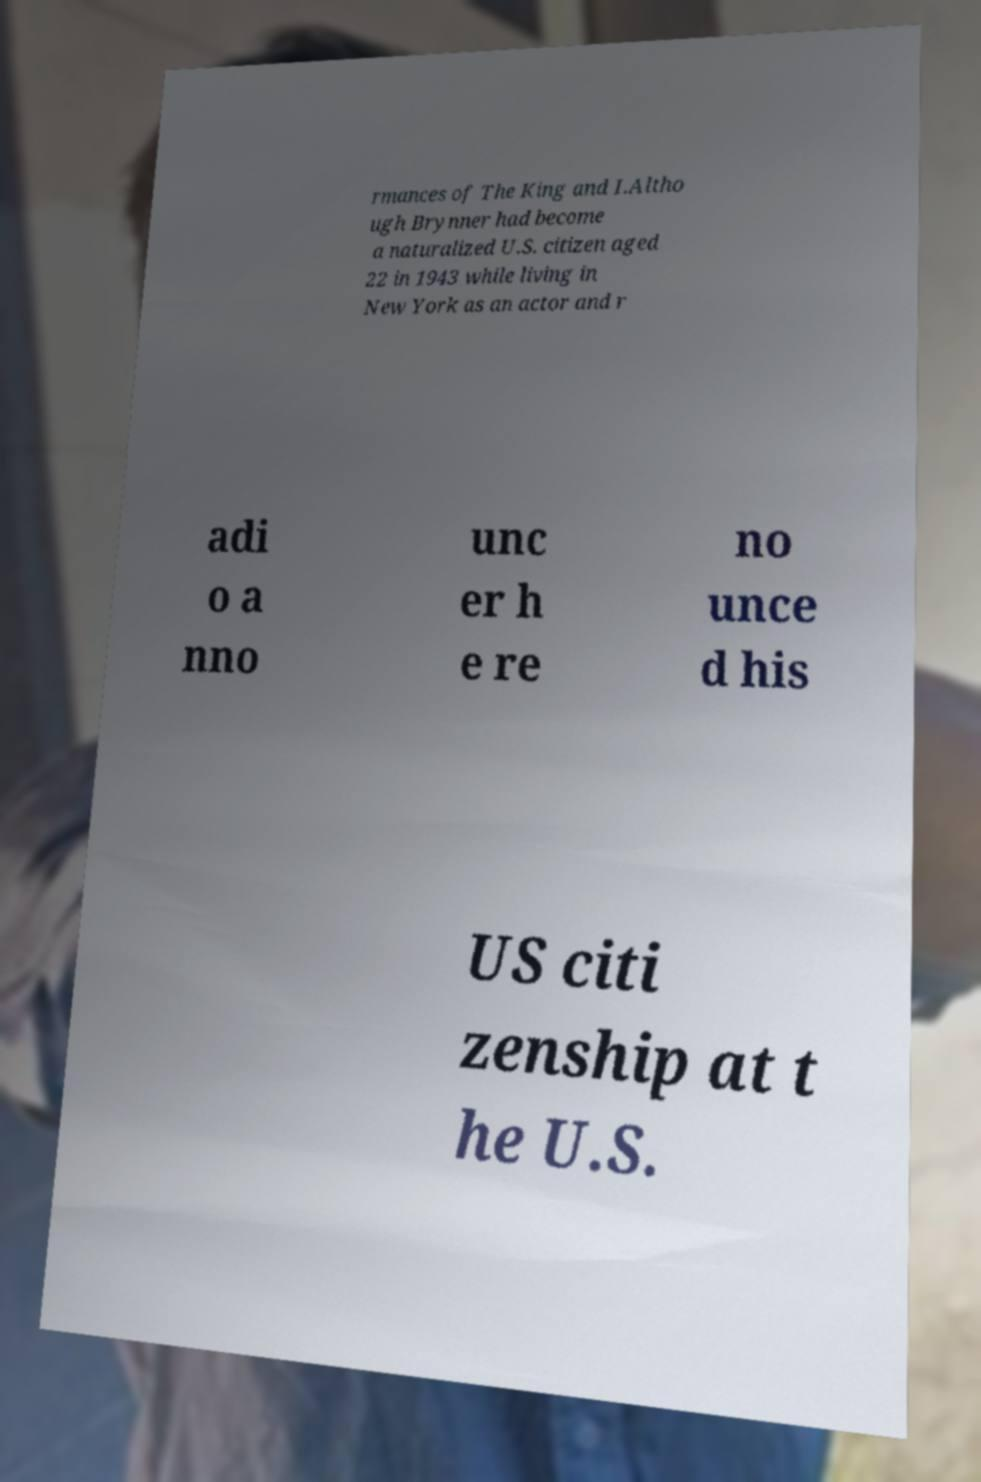I need the written content from this picture converted into text. Can you do that? rmances of The King and I.Altho ugh Brynner had become a naturalized U.S. citizen aged 22 in 1943 while living in New York as an actor and r adi o a nno unc er h e re no unce d his US citi zenship at t he U.S. 